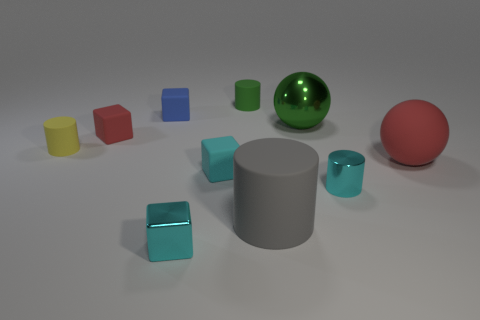Subtract 1 cylinders. How many cylinders are left? 3 Subtract all cylinders. How many objects are left? 6 Add 5 metal blocks. How many metal blocks exist? 6 Subtract 1 blue blocks. How many objects are left? 9 Subtract all tiny cyan metallic objects. Subtract all large red matte things. How many objects are left? 7 Add 5 cyan cubes. How many cyan cubes are left? 7 